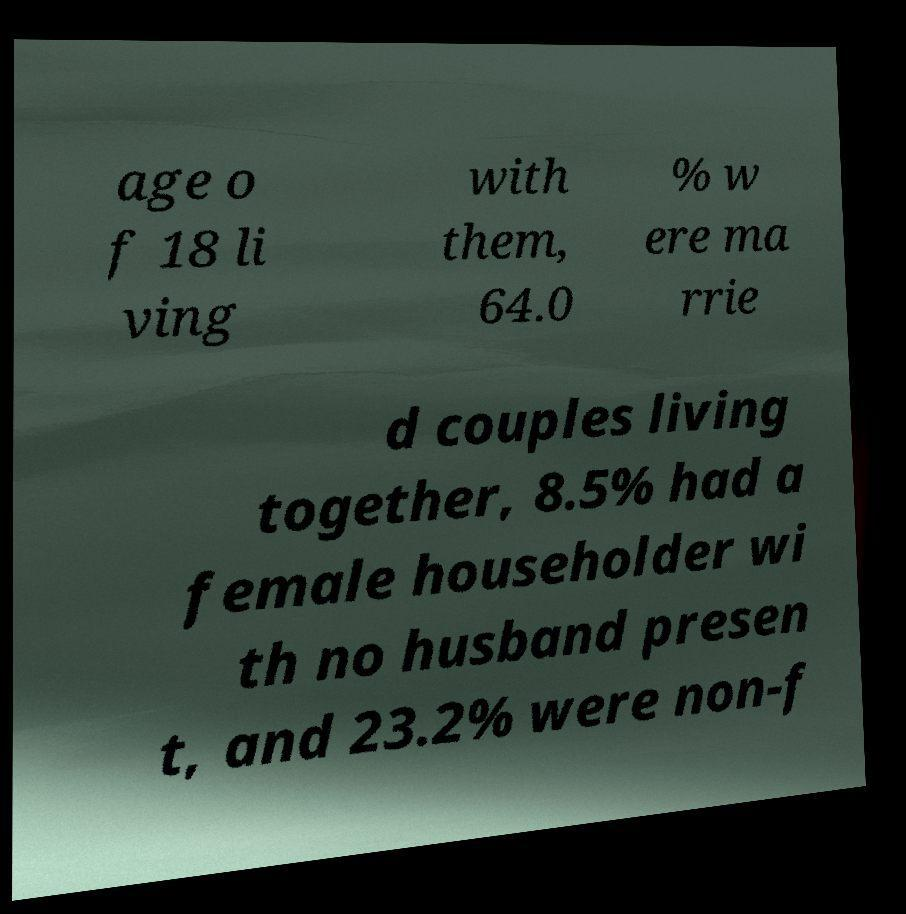For documentation purposes, I need the text within this image transcribed. Could you provide that? age o f 18 li ving with them, 64.0 % w ere ma rrie d couples living together, 8.5% had a female householder wi th no husband presen t, and 23.2% were non-f 